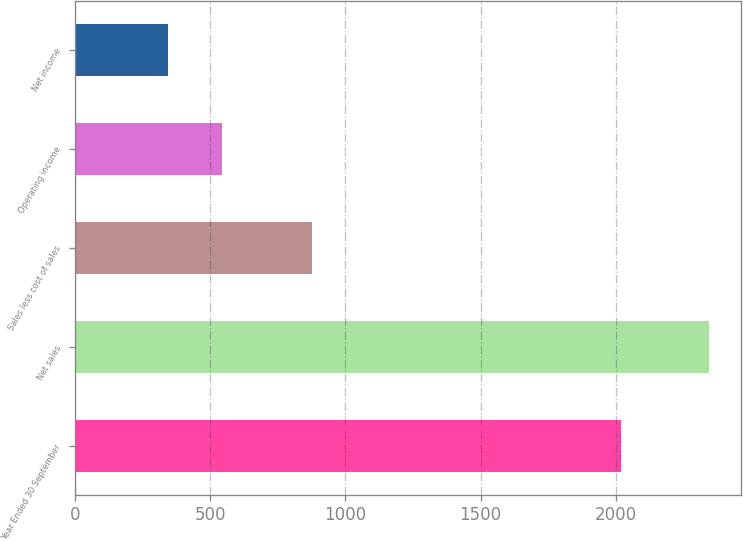<chart> <loc_0><loc_0><loc_500><loc_500><bar_chart><fcel>Year Ended 30 September<fcel>Net sales<fcel>Sales less cost of sales<fcel>Operating income<fcel>Net income<nl><fcel>2017<fcel>2343.3<fcel>878.6<fcel>543.48<fcel>343.5<nl></chart> 